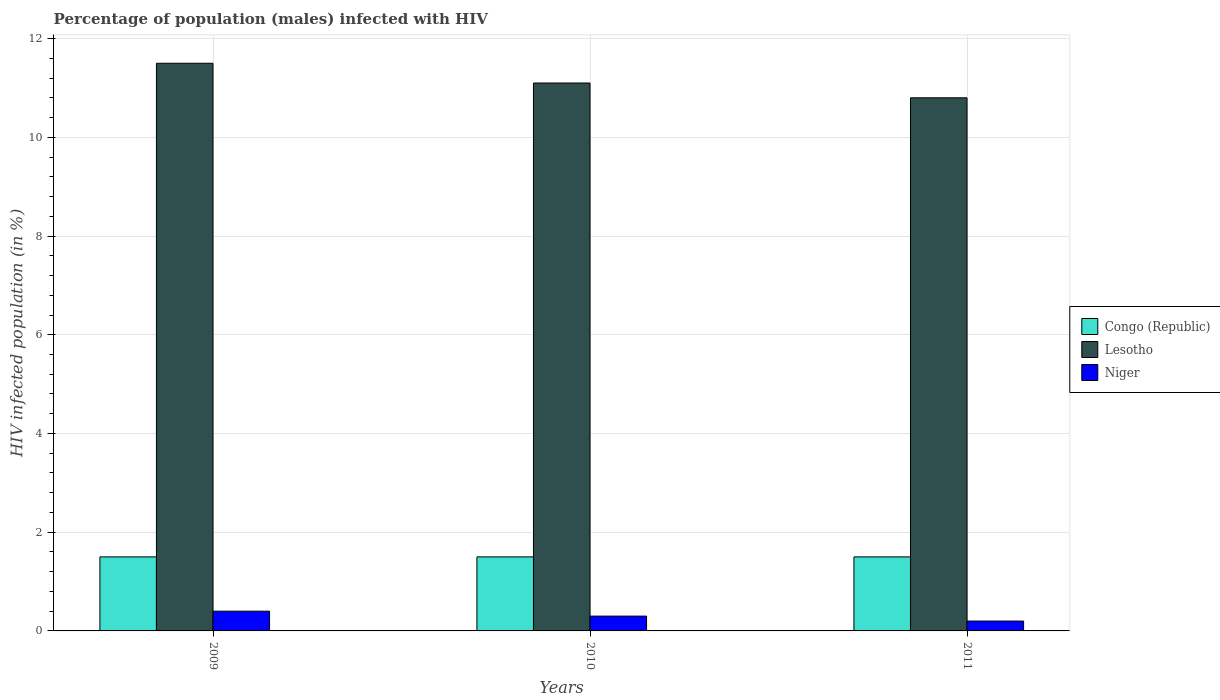How many different coloured bars are there?
Ensure brevity in your answer.  3. How many groups of bars are there?
Provide a short and direct response. 3. Are the number of bars on each tick of the X-axis equal?
Offer a very short reply. Yes. How many bars are there on the 1st tick from the right?
Give a very brief answer. 3. Across all years, what is the maximum percentage of HIV infected male population in Congo (Republic)?
Give a very brief answer. 1.5. In which year was the percentage of HIV infected male population in Lesotho minimum?
Offer a very short reply. 2011. What is the total percentage of HIV infected male population in Niger in the graph?
Keep it short and to the point. 0.9. What is the difference between the percentage of HIV infected male population in Niger in 2009 and that in 2010?
Offer a terse response. 0.1. What is the difference between the percentage of HIV infected male population in Niger in 2011 and the percentage of HIV infected male population in Congo (Republic) in 2010?
Offer a very short reply. -1.3. What is the average percentage of HIV infected male population in Lesotho per year?
Provide a short and direct response. 11.13. In the year 2011, what is the difference between the percentage of HIV infected male population in Congo (Republic) and percentage of HIV infected male population in Niger?
Ensure brevity in your answer.  1.3. What is the ratio of the percentage of HIV infected male population in Lesotho in 2010 to that in 2011?
Make the answer very short. 1.03. Is the difference between the percentage of HIV infected male population in Congo (Republic) in 2009 and 2010 greater than the difference between the percentage of HIV infected male population in Niger in 2009 and 2010?
Keep it short and to the point. No. What is the difference between the highest and the second highest percentage of HIV infected male population in Niger?
Your answer should be compact. 0.1. What is the difference between the highest and the lowest percentage of HIV infected male population in Lesotho?
Make the answer very short. 0.7. In how many years, is the percentage of HIV infected male population in Niger greater than the average percentage of HIV infected male population in Niger taken over all years?
Provide a succinct answer. 1. What does the 1st bar from the left in 2009 represents?
Provide a succinct answer. Congo (Republic). What does the 2nd bar from the right in 2011 represents?
Your answer should be compact. Lesotho. How many bars are there?
Ensure brevity in your answer.  9. Are all the bars in the graph horizontal?
Offer a very short reply. No. What is the difference between two consecutive major ticks on the Y-axis?
Offer a very short reply. 2. Are the values on the major ticks of Y-axis written in scientific E-notation?
Offer a very short reply. No. Where does the legend appear in the graph?
Offer a terse response. Center right. How many legend labels are there?
Offer a very short reply. 3. How are the legend labels stacked?
Make the answer very short. Vertical. What is the title of the graph?
Offer a terse response. Percentage of population (males) infected with HIV. What is the label or title of the Y-axis?
Your response must be concise. HIV infected population (in %). What is the HIV infected population (in %) of Congo (Republic) in 2009?
Offer a terse response. 1.5. What is the HIV infected population (in %) in Lesotho in 2009?
Your answer should be compact. 11.5. What is the HIV infected population (in %) in Niger in 2009?
Give a very brief answer. 0.4. What is the HIV infected population (in %) of Lesotho in 2010?
Your response must be concise. 11.1. What is the HIV infected population (in %) in Niger in 2010?
Give a very brief answer. 0.3. What is the HIV infected population (in %) of Congo (Republic) in 2011?
Provide a short and direct response. 1.5. Across all years, what is the maximum HIV infected population (in %) of Lesotho?
Make the answer very short. 11.5. Across all years, what is the maximum HIV infected population (in %) of Niger?
Provide a short and direct response. 0.4. Across all years, what is the minimum HIV infected population (in %) of Congo (Republic)?
Provide a short and direct response. 1.5. Across all years, what is the minimum HIV infected population (in %) of Lesotho?
Your response must be concise. 10.8. What is the total HIV infected population (in %) of Lesotho in the graph?
Offer a very short reply. 33.4. What is the difference between the HIV infected population (in %) in Congo (Republic) in 2009 and that in 2010?
Your response must be concise. 0. What is the difference between the HIV infected population (in %) of Lesotho in 2009 and that in 2010?
Your answer should be very brief. 0.4. What is the difference between the HIV infected population (in %) in Lesotho in 2009 and that in 2011?
Offer a very short reply. 0.7. What is the difference between the HIV infected population (in %) of Niger in 2009 and that in 2011?
Offer a very short reply. 0.2. What is the difference between the HIV infected population (in %) of Lesotho in 2010 and that in 2011?
Your response must be concise. 0.3. What is the difference between the HIV infected population (in %) in Niger in 2010 and that in 2011?
Provide a succinct answer. 0.1. What is the difference between the HIV infected population (in %) of Congo (Republic) in 2009 and the HIV infected population (in %) of Lesotho in 2010?
Your response must be concise. -9.6. What is the difference between the HIV infected population (in %) in Lesotho in 2009 and the HIV infected population (in %) in Niger in 2010?
Keep it short and to the point. 11.2. What is the difference between the HIV infected population (in %) of Congo (Republic) in 2009 and the HIV infected population (in %) of Lesotho in 2011?
Your answer should be very brief. -9.3. What is the difference between the HIV infected population (in %) of Congo (Republic) in 2009 and the HIV infected population (in %) of Niger in 2011?
Offer a terse response. 1.3. What is the difference between the HIV infected population (in %) of Congo (Republic) in 2010 and the HIV infected population (in %) of Lesotho in 2011?
Provide a short and direct response. -9.3. What is the difference between the HIV infected population (in %) of Congo (Republic) in 2010 and the HIV infected population (in %) of Niger in 2011?
Your response must be concise. 1.3. What is the average HIV infected population (in %) in Congo (Republic) per year?
Provide a short and direct response. 1.5. What is the average HIV infected population (in %) in Lesotho per year?
Give a very brief answer. 11.13. In the year 2009, what is the difference between the HIV infected population (in %) in Congo (Republic) and HIV infected population (in %) in Niger?
Give a very brief answer. 1.1. In the year 2010, what is the difference between the HIV infected population (in %) of Congo (Republic) and HIV infected population (in %) of Lesotho?
Offer a very short reply. -9.6. In the year 2010, what is the difference between the HIV infected population (in %) in Lesotho and HIV infected population (in %) in Niger?
Your answer should be compact. 10.8. What is the ratio of the HIV infected population (in %) of Lesotho in 2009 to that in 2010?
Provide a succinct answer. 1.04. What is the ratio of the HIV infected population (in %) of Niger in 2009 to that in 2010?
Make the answer very short. 1.33. What is the ratio of the HIV infected population (in %) of Lesotho in 2009 to that in 2011?
Offer a very short reply. 1.06. What is the ratio of the HIV infected population (in %) in Congo (Republic) in 2010 to that in 2011?
Offer a very short reply. 1. What is the ratio of the HIV infected population (in %) in Lesotho in 2010 to that in 2011?
Your answer should be very brief. 1.03. What is the ratio of the HIV infected population (in %) of Niger in 2010 to that in 2011?
Provide a short and direct response. 1.5. What is the difference between the highest and the second highest HIV infected population (in %) of Congo (Republic)?
Make the answer very short. 0. What is the difference between the highest and the second highest HIV infected population (in %) in Lesotho?
Make the answer very short. 0.4. What is the difference between the highest and the second highest HIV infected population (in %) in Niger?
Your response must be concise. 0.1. What is the difference between the highest and the lowest HIV infected population (in %) in Niger?
Provide a short and direct response. 0.2. 